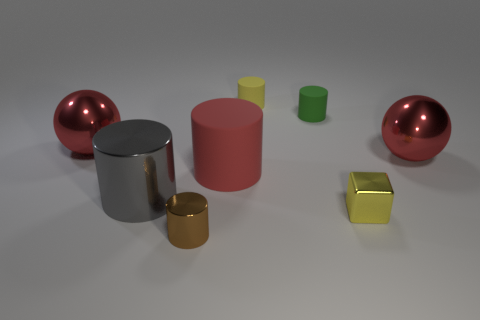What number of other objects are the same material as the gray object?
Your response must be concise. 4. What is the material of the brown cylinder?
Ensure brevity in your answer.  Metal. What is the size of the object that is right of the yellow cube?
Your answer should be very brief. Large. What number of big matte cylinders are behind the large red shiny ball that is on the left side of the brown cylinder?
Your response must be concise. 0. Is the shape of the large red object to the right of the green thing the same as the green matte thing that is behind the big gray metallic cylinder?
Ensure brevity in your answer.  No. How many objects are in front of the yellow rubber thing and behind the brown object?
Provide a succinct answer. 6. Is there a large ball of the same color as the big rubber cylinder?
Provide a succinct answer. Yes. There is a yellow object that is the same size as the metallic block; what shape is it?
Your response must be concise. Cylinder. Are there any tiny metallic objects on the left side of the gray object?
Provide a succinct answer. No. Does the sphere that is to the left of the yellow rubber thing have the same material as the red ball that is right of the yellow cube?
Your answer should be compact. Yes. 